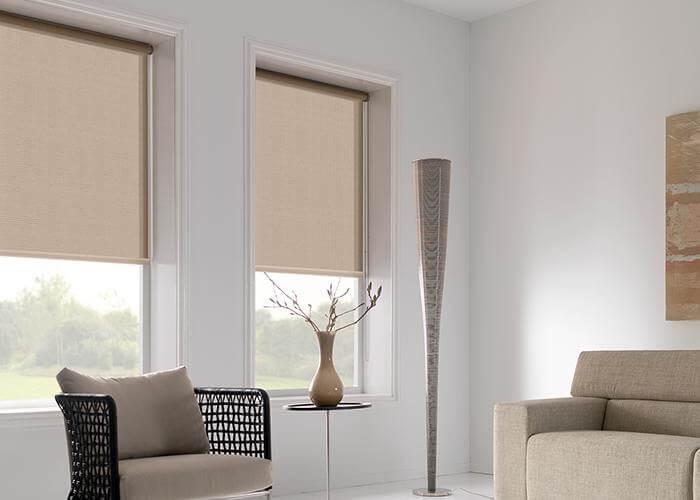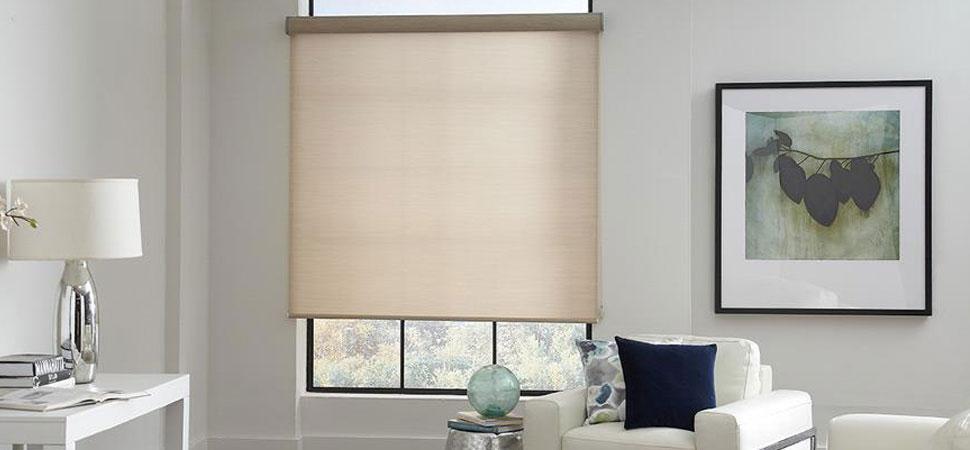The first image is the image on the left, the second image is the image on the right. For the images shown, is this caption "There are exactly three window shades." true? Answer yes or no. Yes. The first image is the image on the left, the second image is the image on the right. Examine the images to the left and right. Is the description "The left and right image contains a total of three blinds." accurate? Answer yes or no. Yes. 